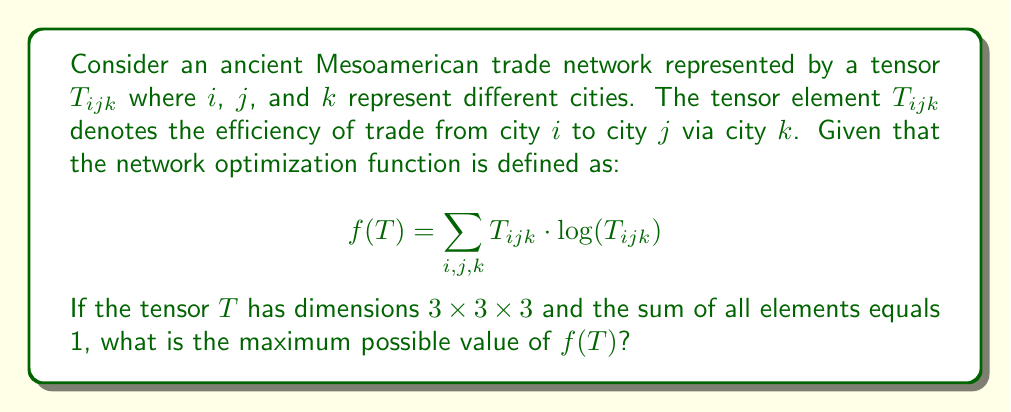Provide a solution to this math problem. To solve this problem, we'll follow these steps:

1) First, recall that the function $x \log(x)$ reaches its maximum value when $x = 1/e$, where $e$ is Euler's number.

2) The optimization function $f(T)$ is a sum of terms of the form $T_{ijk} \log(T_{ijk})$. To maximize this sum, we want as many terms as possible to be equal to $1/e$.

3) Given that the tensor has dimensions $3 \times 3 \times 3$, there are 27 elements in total.

4) We're told that the sum of all elements equals 1. This means we can have at most $\lfloor e \rfloor = 2$ elements equal to $1/e$, as $3/e > 1$.

5) The remaining $27 - 2 = 25$ elements must sum to $1 - 2/e$.

6) Therefore, the maximum value of $f(T)$ will occur when:
   - 2 elements equal $1/e$
   - 25 elements equal $(1 - 2/e)/25$

7) Let's calculate the value of $f(T)$ in this case:

   $$f(T) = 2 \cdot \frac{1}{e} \log(\frac{1}{e}) + 25 \cdot \frac{1 - 2/e}{25} \log(\frac{1 - 2/e}{25})$$

8) Simplify:

   $$f(T) = -\frac{2}{e} + (1 - \frac{2}{e}) \log(\frac{1 - 2/e}{25})$$

9) This is the maximum possible value of $f(T)$ given the constraints.
Answer: $-\frac{2}{e} + (1 - \frac{2}{e}) \log(\frac{1 - 2/e}{25})$ 